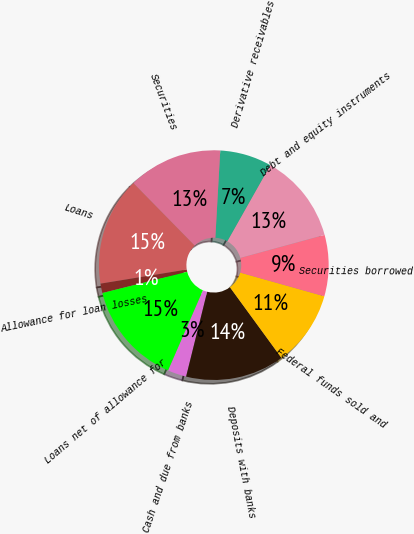Convert chart to OTSL. <chart><loc_0><loc_0><loc_500><loc_500><pie_chart><fcel>Cash and due from banks<fcel>Deposits with banks<fcel>Federal funds sold and<fcel>Securities borrowed<fcel>Debt and equity instruments<fcel>Derivative receivables<fcel>Securities<fcel>Loans<fcel>Allowance for loan losses<fcel>Loans net of allowance for<nl><fcel>2.65%<fcel>13.91%<fcel>10.6%<fcel>8.61%<fcel>12.58%<fcel>7.29%<fcel>13.24%<fcel>15.23%<fcel>1.33%<fcel>14.57%<nl></chart> 